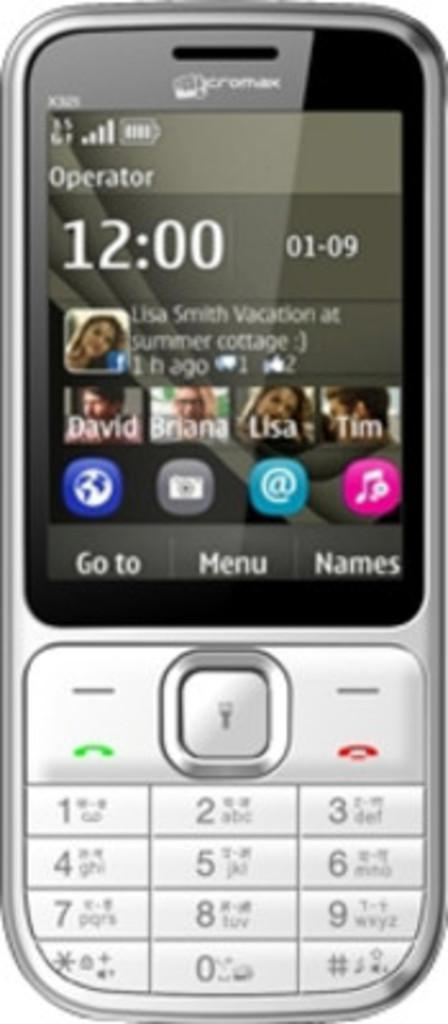Provide a one-sentence caption for the provided image. an old cellphone has the numbers x325 written in the upper left hand corner. 